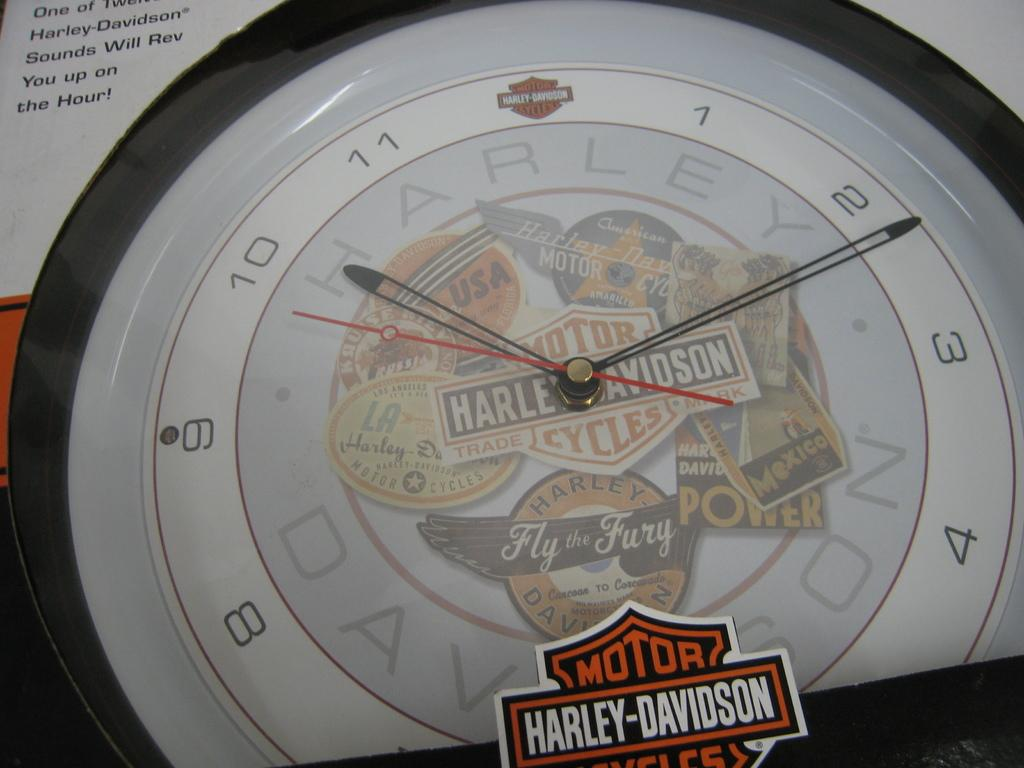<image>
Offer a succinct explanation of the picture presented. A clock has Harley Davidson written on it in multiple places 